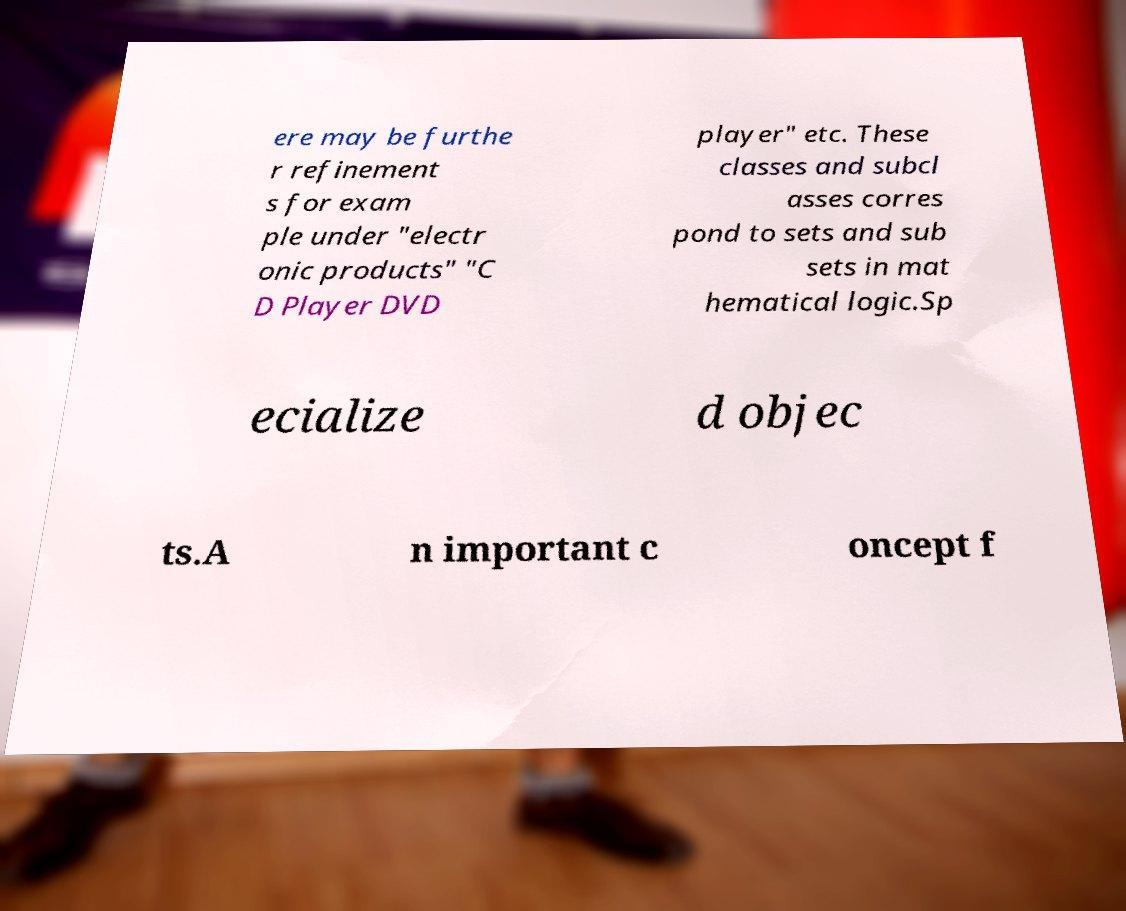I need the written content from this picture converted into text. Can you do that? ere may be furthe r refinement s for exam ple under "electr onic products" "C D Player DVD player" etc. These classes and subcl asses corres pond to sets and sub sets in mat hematical logic.Sp ecialize d objec ts.A n important c oncept f 